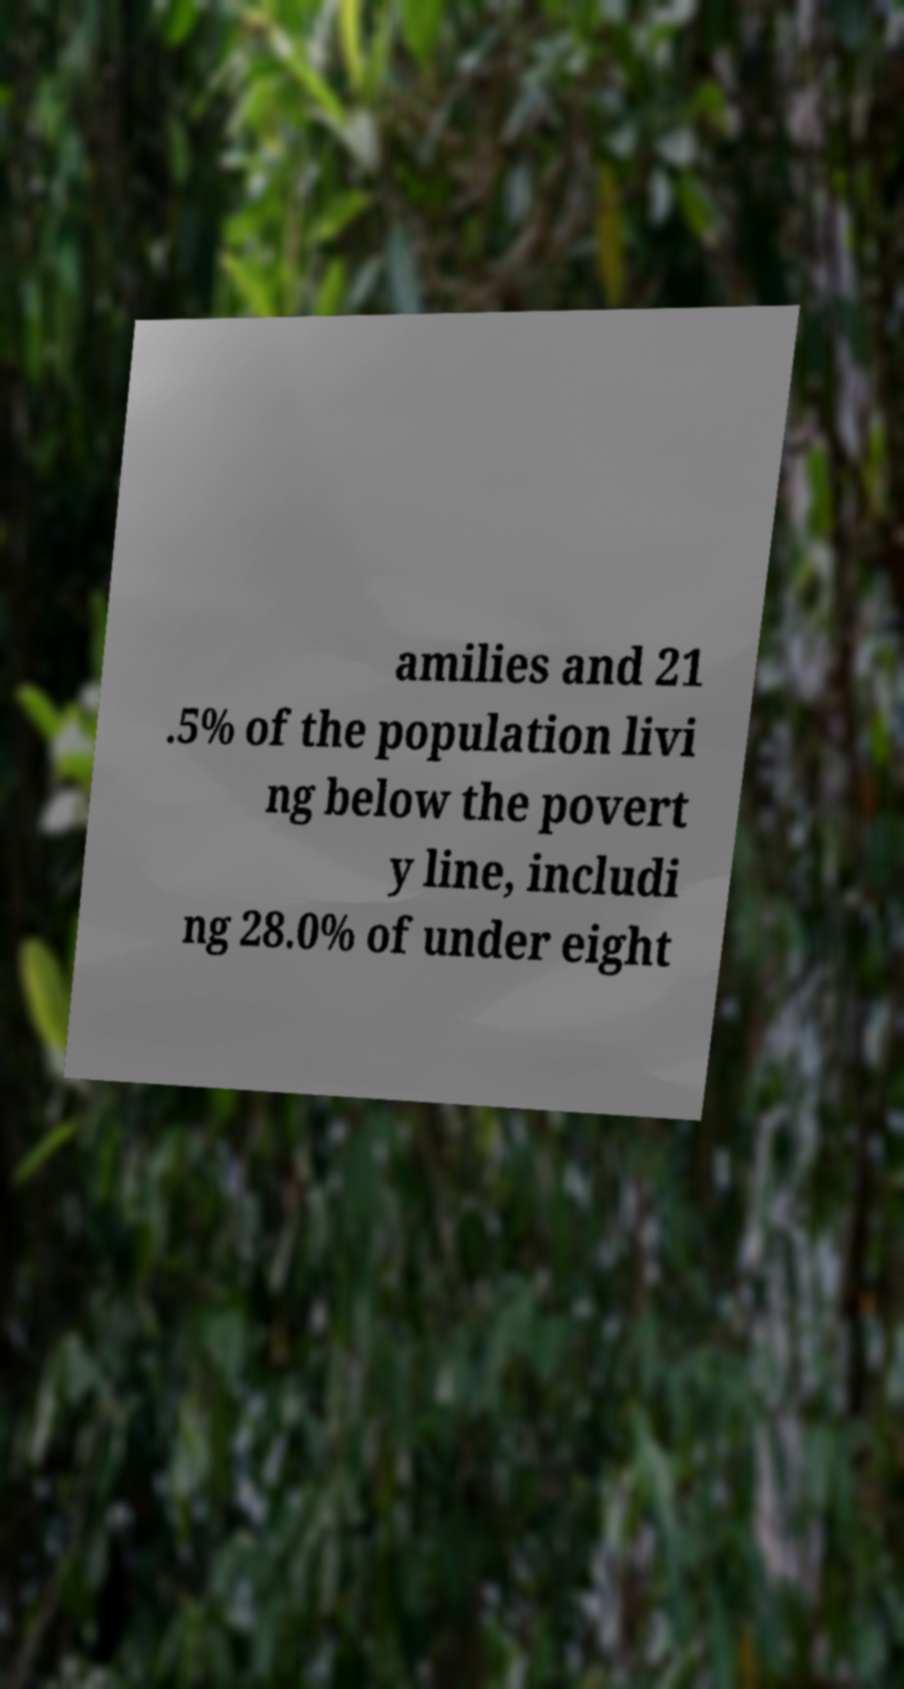Please identify and transcribe the text found in this image. amilies and 21 .5% of the population livi ng below the povert y line, includi ng 28.0% of under eight 